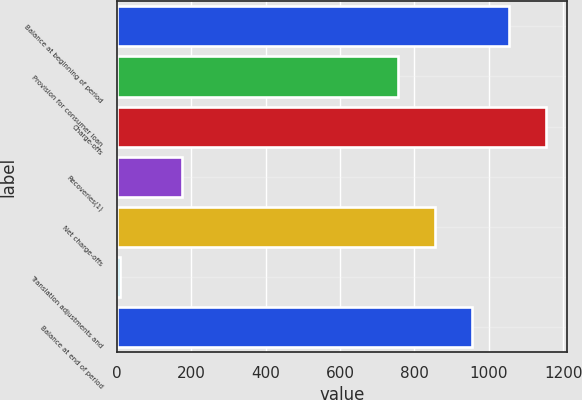Convert chart. <chart><loc_0><loc_0><loc_500><loc_500><bar_chart><fcel>Balance at beginning of period<fcel>Provision for consumer loan<fcel>Charge-offs<fcel>Recoveries(1)<fcel>Net charge-offs<fcel>Translation adjustments and<fcel>Balance at end of period<nl><fcel>1053.6<fcel>756<fcel>1152.8<fcel>174<fcel>855.2<fcel>9<fcel>954.4<nl></chart> 